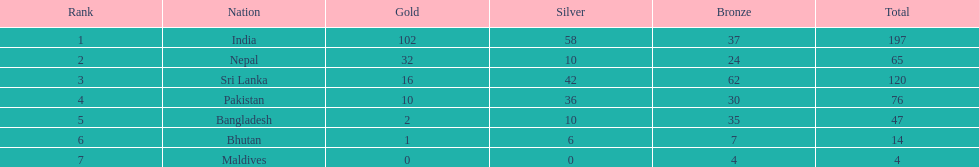Which nation has earned the least amount of gold medals? Maldives. 